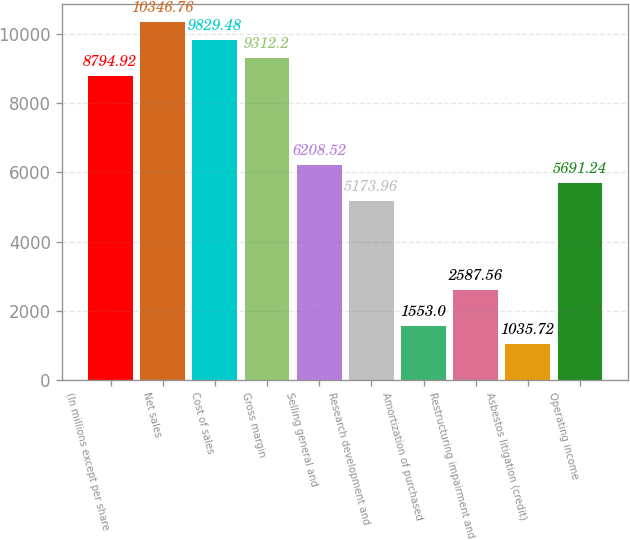Convert chart to OTSL. <chart><loc_0><loc_0><loc_500><loc_500><bar_chart><fcel>(In millions except per share<fcel>Net sales<fcel>Cost of sales<fcel>Gross margin<fcel>Selling general and<fcel>Research development and<fcel>Amortization of purchased<fcel>Restructuring impairment and<fcel>Asbestos litigation (credit)<fcel>Operating income<nl><fcel>8794.92<fcel>10346.8<fcel>9829.48<fcel>9312.2<fcel>6208.52<fcel>5173.96<fcel>1553<fcel>2587.56<fcel>1035.72<fcel>5691.24<nl></chart> 